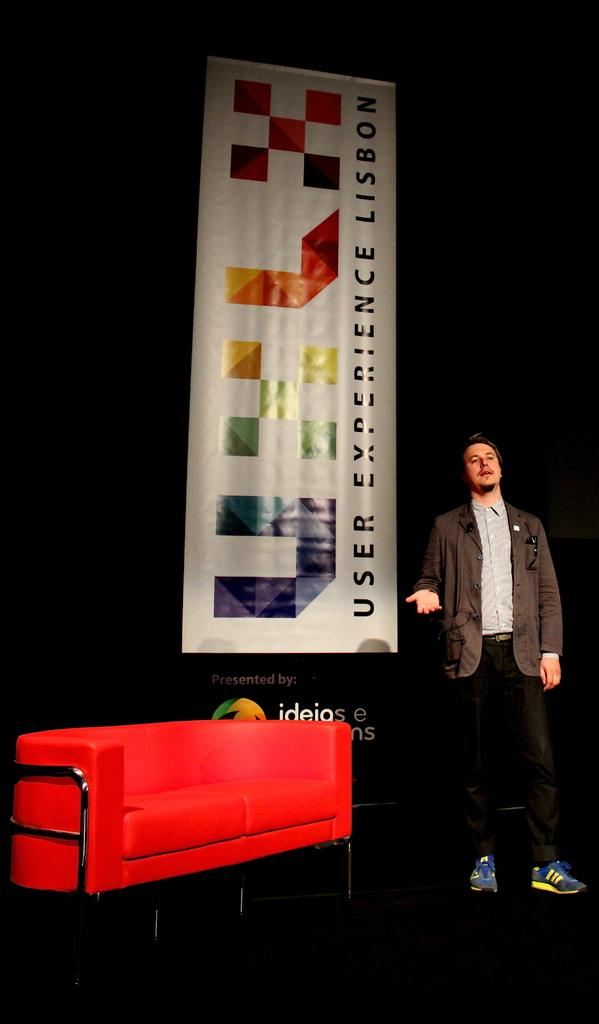What is the man doing in the image? The man is standing on a stage and speaking in the image. What is located beside the man on the stage? There is a couch beside the man on the stage. What can be seen behind the man on the stage? There is a banner present behind the man on the stage. Can you see the man's daughter playing on the playground in the image? There is no playground or daughter present in the image; it features a man standing on a stage and speaking. 